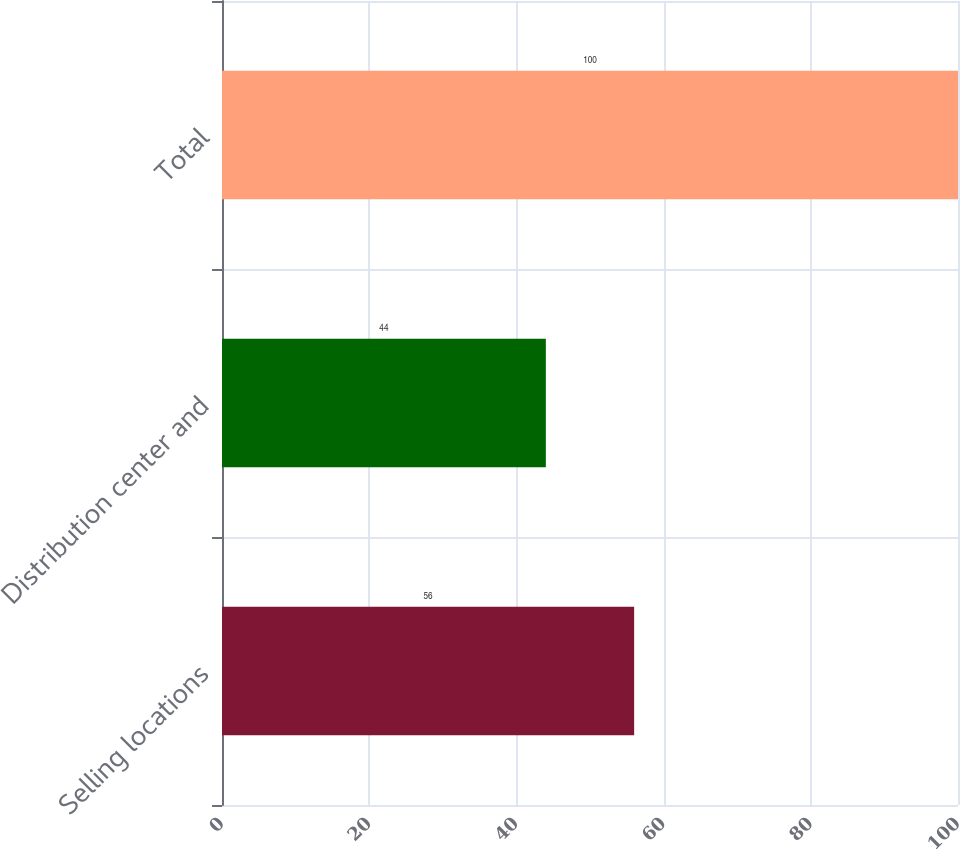Convert chart. <chart><loc_0><loc_0><loc_500><loc_500><bar_chart><fcel>Selling locations<fcel>Distribution center and<fcel>Total<nl><fcel>56<fcel>44<fcel>100<nl></chart> 